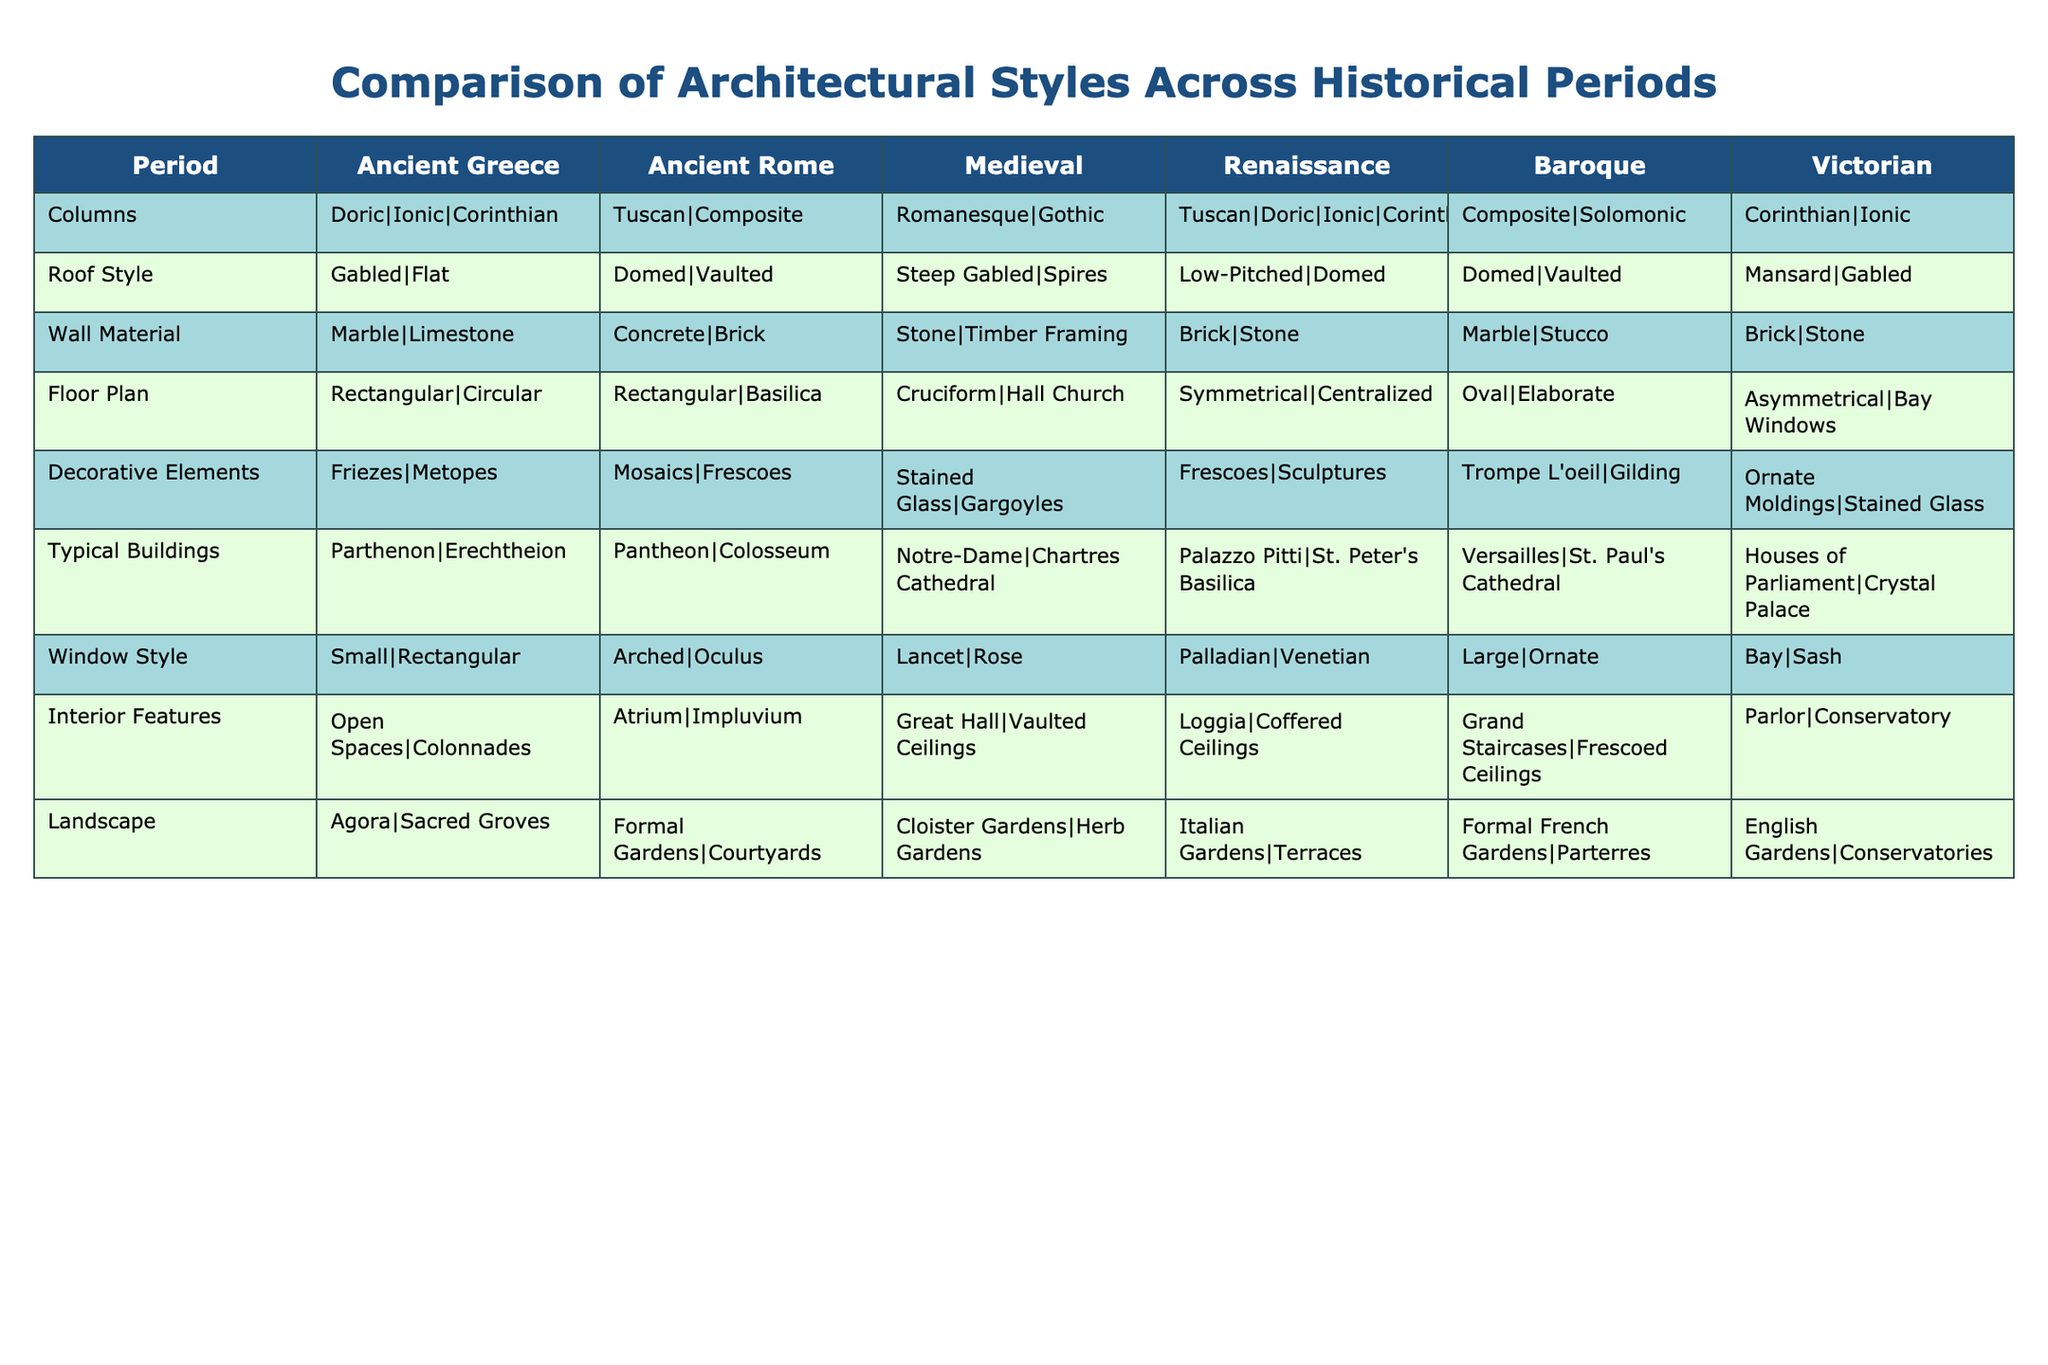What architectural style is characterized by pointed arches? The pointed arches are typical of the Gothic style, which falls under the Medieval period. The table lists Romanesque and Gothic styles under the Medieval category.
Answer: Gothic Which roof style is common in Renaissance architecture? The Renaissance architecture commonly features domed roofs as indicated in the table under the Renaissance period.
Answer: Domed In which period is the use of gilt decorative elements prevalent? The table shows that gilding as a decorative element is associated with the Baroque period.
Answer: Baroque What is the main wall material used in Victorian architecture? Under the Victorian period, the primary wall materials used are brick and stone according to the table.
Answer: Brick and stone Which period features the largest window style? The table indicates that large and ornate window styles are typical of the Baroque period in architecture.
Answer: Baroque How many different types of roof styles are listed in the Ancient Greek period? The Ancient Greek period features two types of roof styles, namely gabled and flat. This is noted in the corresponding cell.
Answer: 2 Which period uses the Tuscan column style? The Tuscan column style is noted in both the Renaissance and Baroque periods. Therefore, it is used in those two historical periods according to the table.
Answer: Renaissance and Baroque What is the typical building from the Ancient Rome period that uses concrete? The Pantheon is recorded in the table as a typical building of the Ancient Rome period, which commonly uses concrete for construction.
Answer: Pantheon Is timber framing used in Medieval architecture? The table states that timber framing is used in Medieval architecture, specifically under the Romanesque category.
Answer: Yes Which historical period has the most distinct landscape features? The Victorian period stands out with its distinctive landscape features such as English gardens and conservatories noted in the table.
Answer: Victorian During which period did architectural decorative elements, such as stained glass, become prominent? The Medieval period prominently featured stained glass as a decorative element as mentioned in the table.
Answer: Medieval What is the difference in floor plan styles between Renaissance and Victorian architecture? The Renaissance features mostly symmetrical and centralized floor plans, while the Victorian architecture has asymmetrical plans with bay windows.
Answer: Symmetrical vs. Asymmetrical 